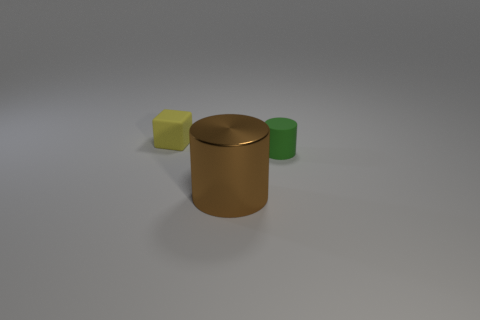Add 1 small green spheres. How many objects exist? 4 Subtract all gray cubes. Subtract all yellow spheres. How many cubes are left? 1 Subtract all cubes. How many objects are left? 2 Add 1 yellow cubes. How many yellow cubes exist? 2 Subtract 0 green balls. How many objects are left? 3 Subtract all matte cylinders. Subtract all tiny green rubber things. How many objects are left? 1 Add 2 shiny cylinders. How many shiny cylinders are left? 3 